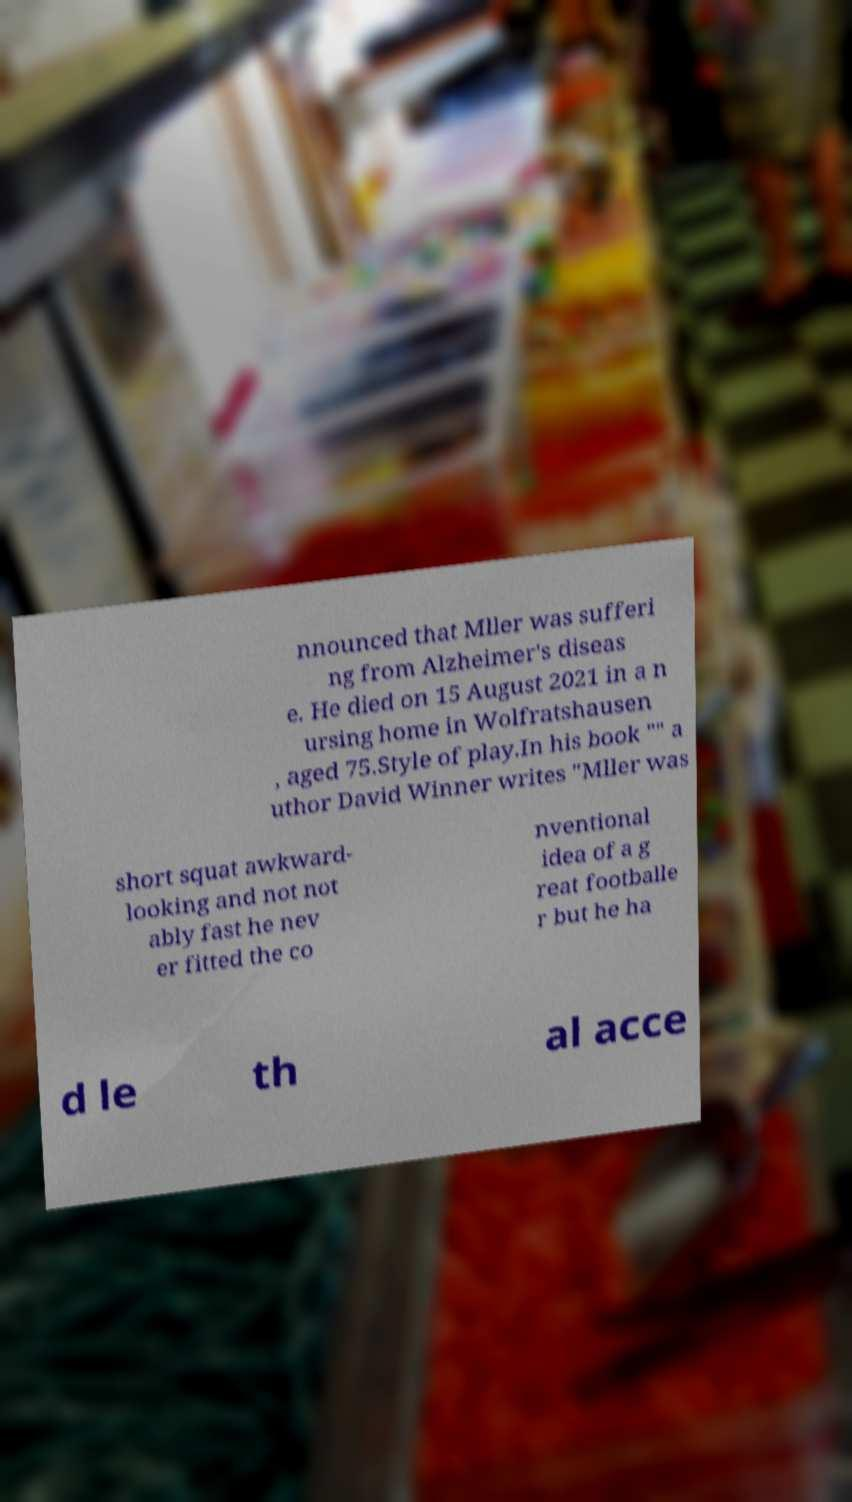Please identify and transcribe the text found in this image. nnounced that Mller was sufferi ng from Alzheimer's diseas e. He died on 15 August 2021 in a n ursing home in Wolfratshausen , aged 75.Style of play.In his book "" a uthor David Winner writes "Mller was short squat awkward- looking and not not ably fast he nev er fitted the co nventional idea of a g reat footballe r but he ha d le th al acce 